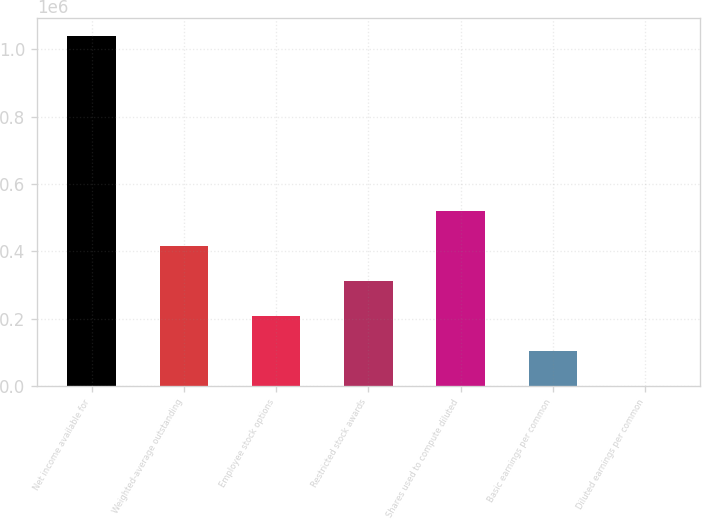Convert chart to OTSL. <chart><loc_0><loc_0><loc_500><loc_500><bar_chart><fcel>Net income available for<fcel>Weighted-average outstanding<fcel>Employee stock options<fcel>Restricted stock awards<fcel>Shares used to compute diluted<fcel>Basic earnings per common<fcel>Diluted earnings per common<nl><fcel>1.03968e+06<fcel>415874<fcel>207940<fcel>311907<fcel>519841<fcel>103973<fcel>6.15<nl></chart> 